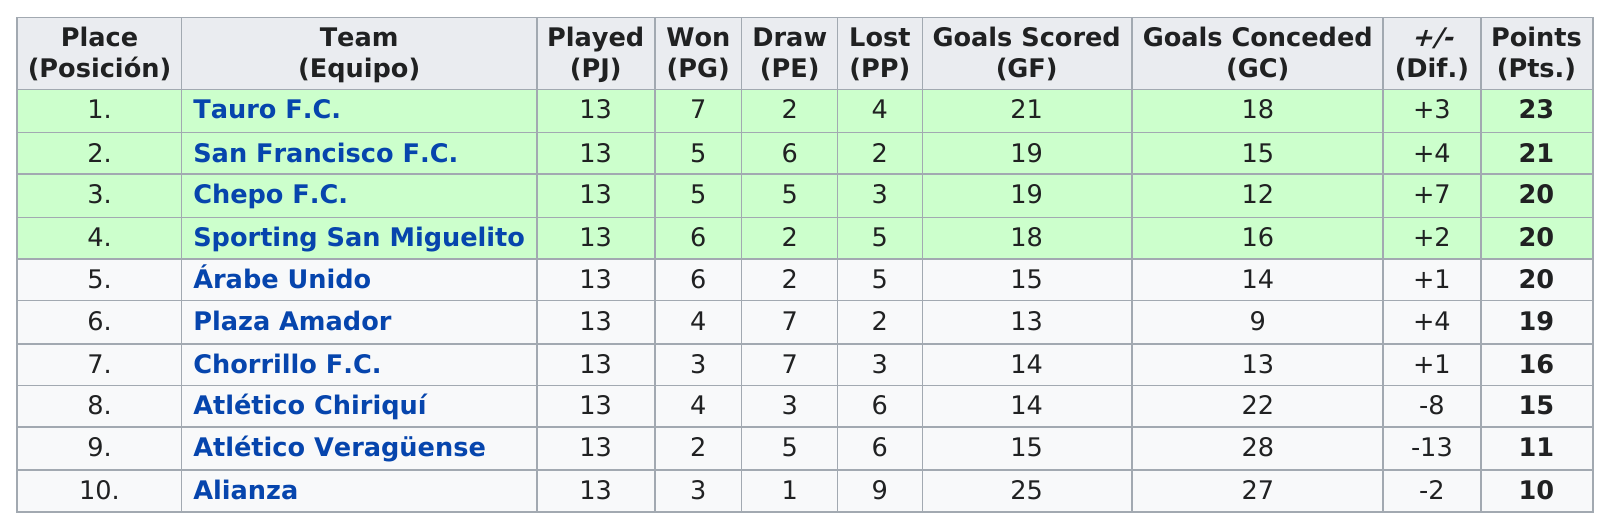Specify some key components in this picture. Chorrillos F.C. has won a total of 3 games. Atlético Veragüense conceded the most goals during the match. Of the five teams that scored at least 17 goals, how many teams scored at least 17 goals? Chorrillo FC finished in second place after Plaza Amador in the Apertura 2008 standings. Tauro F.C. emerged victorious at the top of the Apertura 2008 standings, securing their position as the top team in the league. 